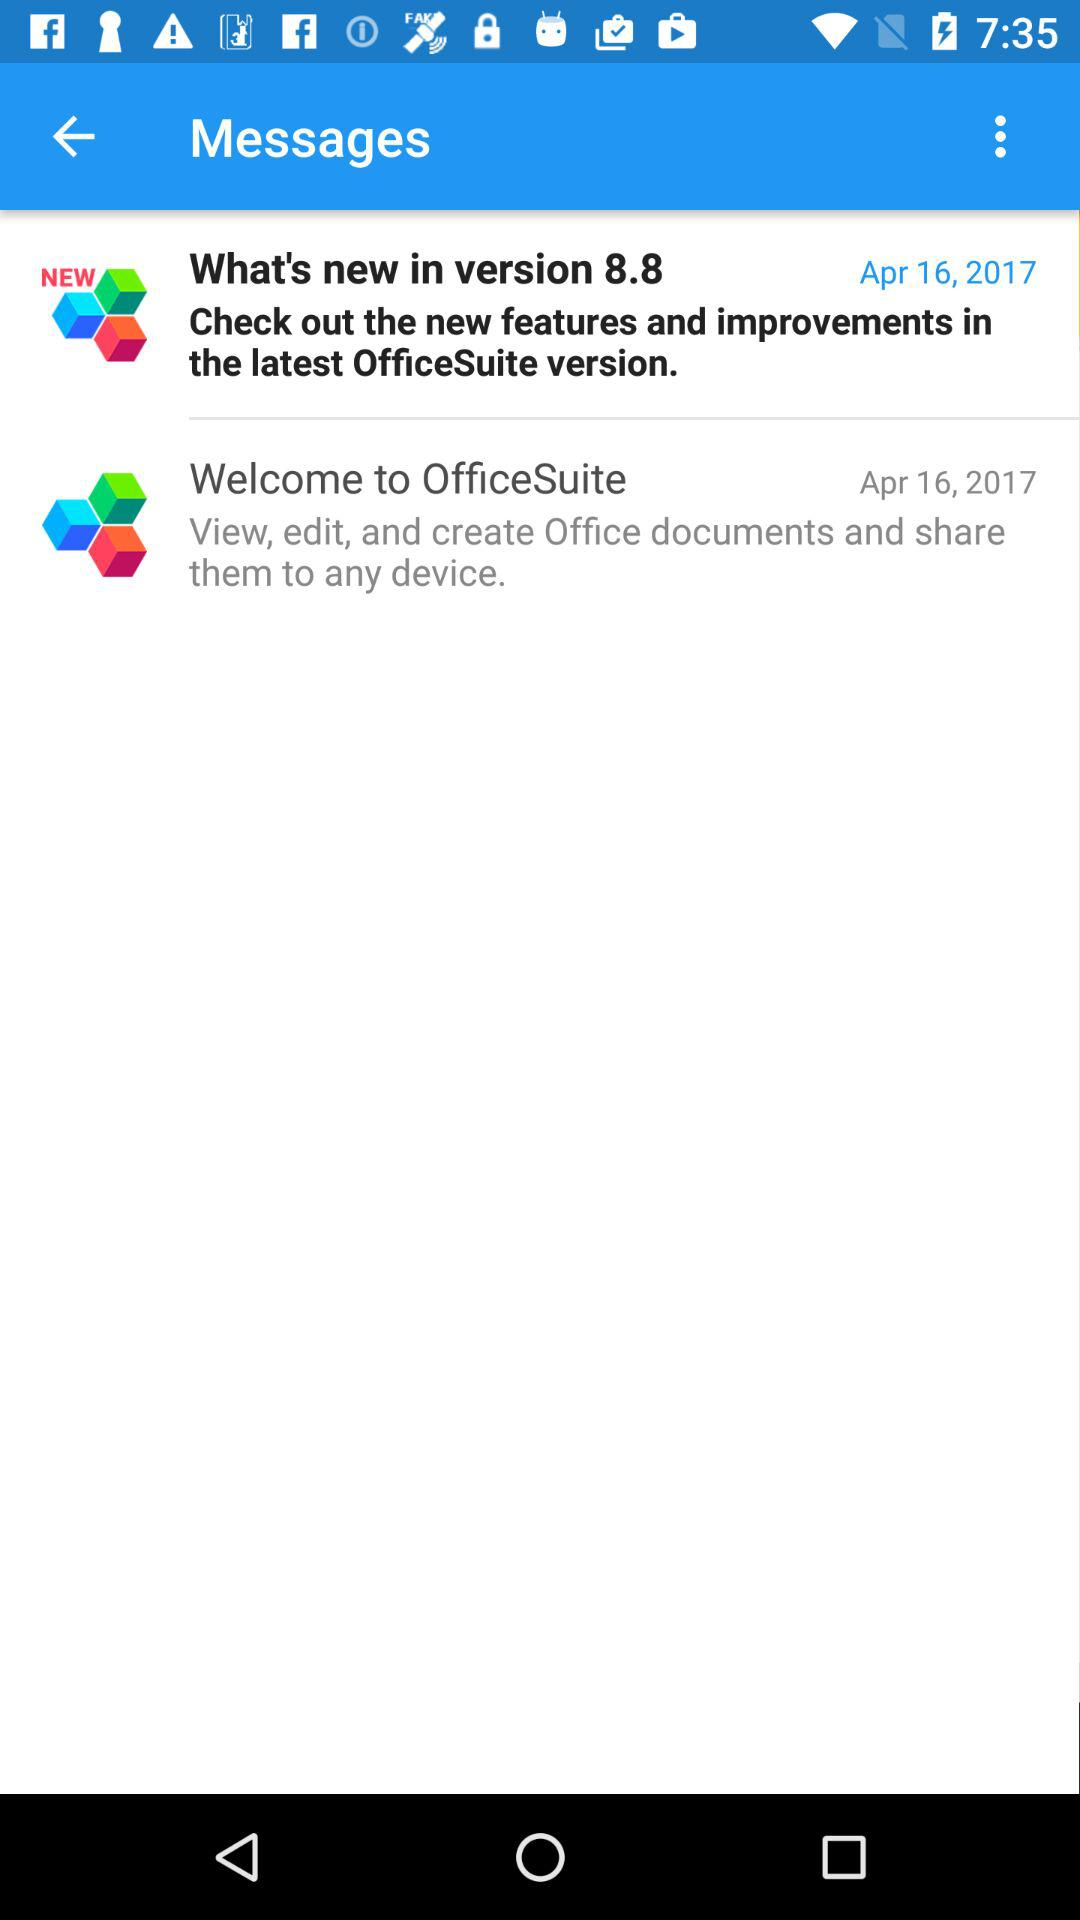On what date did you receive the "Welcome to OfficeSuite" message? The message was received on April 16, 2017. 